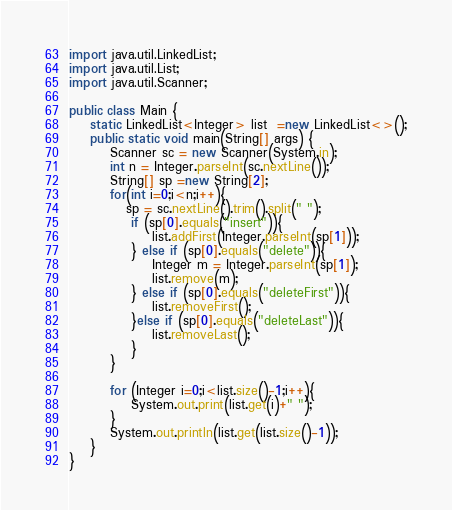Convert code to text. <code><loc_0><loc_0><loc_500><loc_500><_Java_>
import java.util.LinkedList;
import java.util.List;
import java.util.Scanner;

public class Main {
    static LinkedList<Integer> list  =new LinkedList<>();
    public static void main(String[] args) {
        Scanner sc = new Scanner(System.in);
        int n = Integer.parseInt(sc.nextLine());
        String[] sp =new String[2];
        for(int i=0;i<n;i++){
           sp = sc.nextLine().trim().split(" ");
            if (sp[0].equals("insert")){
                list.addFirst(Integer.parseInt(sp[1]));
            } else if (sp[0].equals("delete")){
                Integer m = Integer.parseInt(sp[1]);
                list.remove(m);
            } else if (sp[0].equals("deleteFirst")){
                list.removeFirst();
            }else if (sp[0].equals("deleteLast")){
                list.removeLast();
            }
        }

        for (Integer i=0;i<list.size()-1;i++){
            System.out.print(list.get(i)+" ");
        }
        System.out.println(list.get(list.size()-1));
    }
}

</code> 